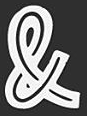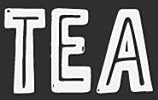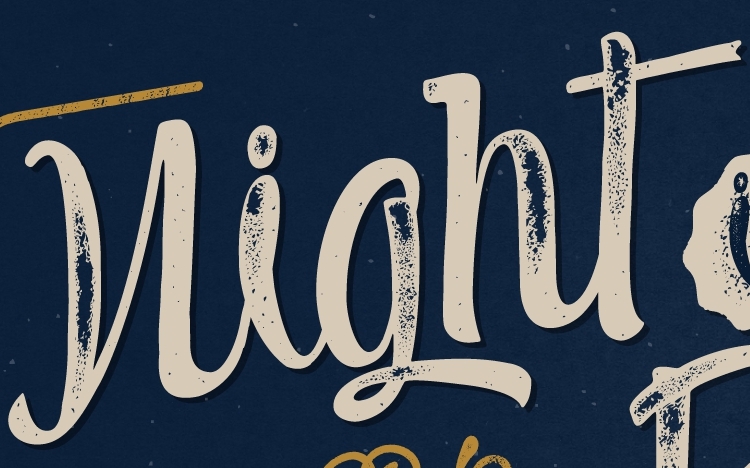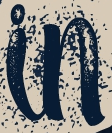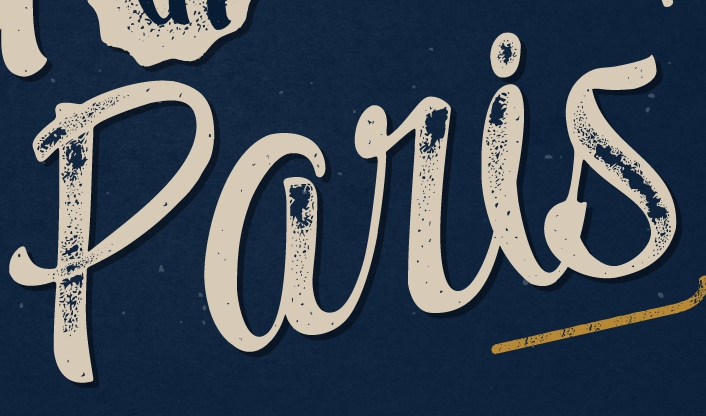What words are shown in these images in order, separated by a semicolon? &; TEA; night; in; paris 